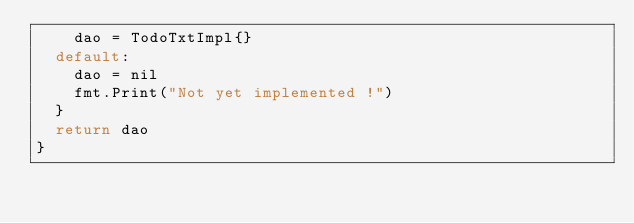Convert code to text. <code><loc_0><loc_0><loc_500><loc_500><_Go_>		dao = TodoTxtImpl{}
	default:
		dao = nil
		fmt.Print("Not yet implemented !")
	}
	return dao
}
</code> 